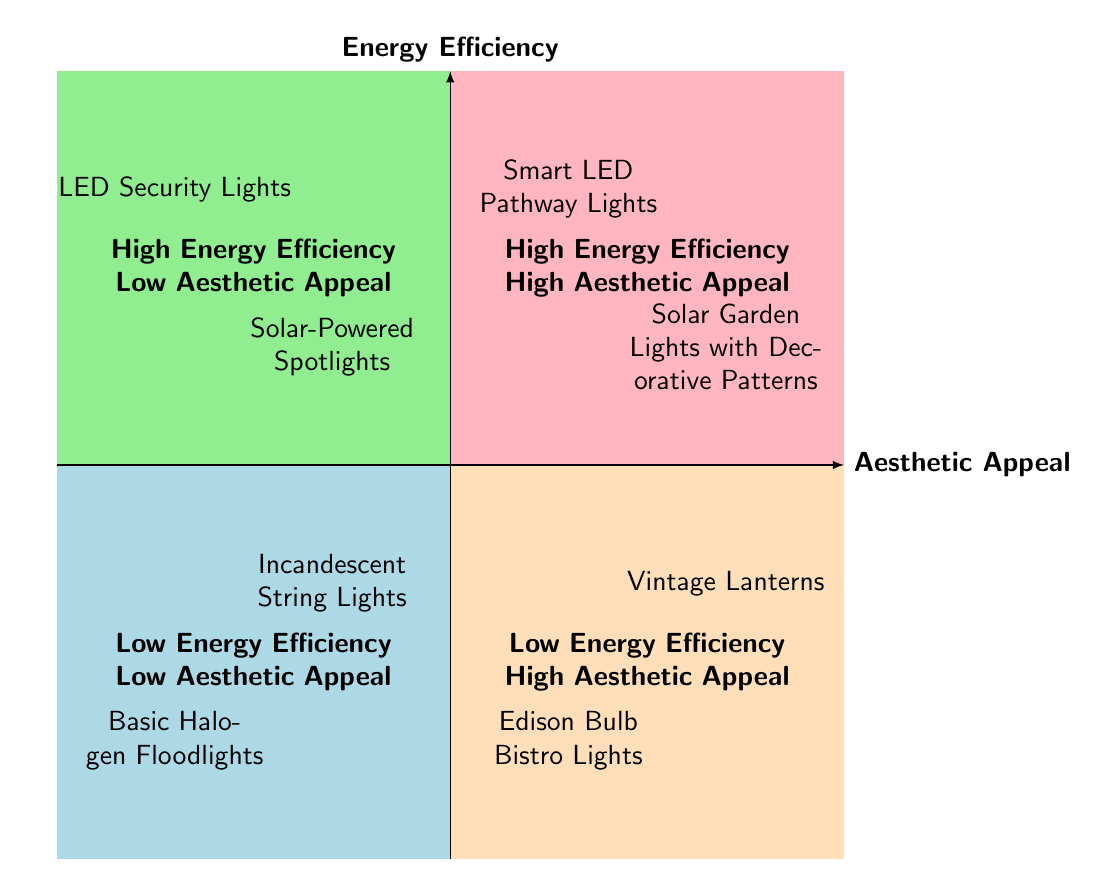What type of lighting is found in the High Energy Efficiency-Low Aesthetic Appeal quadrant? The diagram shows "LED Security Lights" and "Solar-Powered Spotlights" located in the High Energy Efficiency-Low Aesthetic Appeal quadrant.
Answer: LED Security Lights, Solar-Powered Spotlights How many items are in the Low Energy Efficiency-High Aesthetic Appeal quadrant? There are two items listed: "Edison Bulb Bistro Lights" and "Vintage Lanterns." Counting these gives us a total of 2 items.
Answer: 2 What is the primary characteristic of the lights in the Low Energy Efficiency-Low Aesthetic Appeal quadrant? The items in this quadrant, including "Basic Halogen Floodlights" and "Incandescent String Lights," are characterized by both low energy efficiency and low aesthetic appeal, indicating they are not visually attractive and consume a lot of energy.
Answer: Low energy efficiency, low aesthetic appeal Which lighting options represent the combination of high energy efficiency and high aesthetic appeal? The quadrant shows "Smart LED Pathway Lights" and "Solar Garden Lights with Decorative Patterns," both of which combine high energy efficiency with good aesthetic appeal.
Answer: Smart LED Pathway Lights, Solar Garden Lights with Decorative Patterns Which quadrant contains items with the highest energy efficiency? The High Energy Efficiency-Low Aesthetic Appeal quadrant contains items like "LED Security Lights" and "Solar-Powered Spotlights," which both emphasize energy efficiency.
Answer: High Energy Efficiency-Low Aesthetic Appeal Are there any items that show low energy efficiency but high aesthetic appeal? Yes, "Edison Bulb Bistro Lights" and "Vintage Lanterns" both fall into the Low Energy Efficiency-High Aesthetic Appeal quadrant, indicating they prioritize appearance over energy savings.
Answer: Yes What is the aesthetic appeal of the items in the High Energy Efficiency-Low Aesthetic Appeal quadrant? The items listed there, "LED Security Lights" and "Solar-Powered Spotlights," are focused on functionality rather than aesthetics, leading to low aesthetic appeal.
Answer: Low aesthetic appeal How many quadrants are represented in the diagram? There are four quadrants depicted: Low Energy Efficiency-Low Aesthetic Appeal, Low Energy Efficiency-High Aesthetic Appeal, High Energy Efficiency-Low Aesthetic Appeal, and High Energy Efficiency-High Aesthetic Appeal, totaling four quadrants.
Answer: 4 